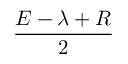Convert formula to latex. <formula><loc_0><loc_0><loc_500><loc_500>\frac { E - \lambda + R } { 2 }</formula> 